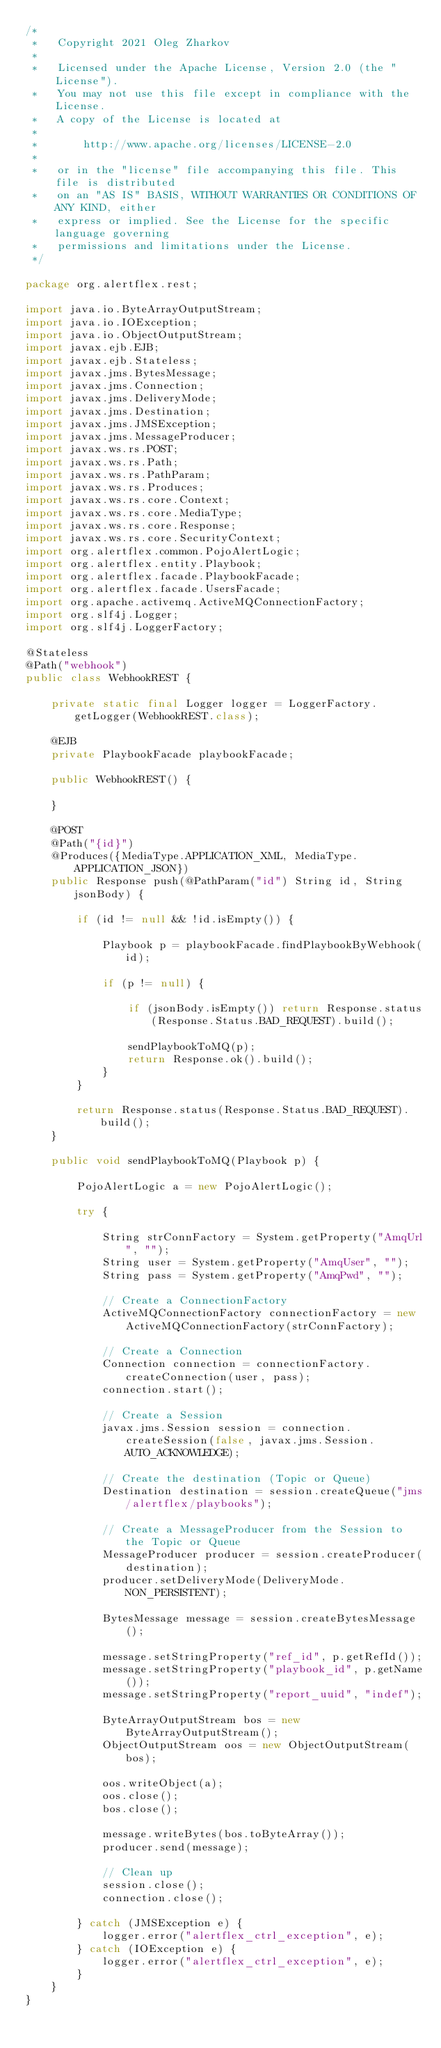Convert code to text. <code><loc_0><loc_0><loc_500><loc_500><_Java_>/*
 *   Copyright 2021 Oleg Zharkov
 *
 *   Licensed under the Apache License, Version 2.0 (the "License").
 *   You may not use this file except in compliance with the License.
 *   A copy of the License is located at
 *
 *       http://www.apache.org/licenses/LICENSE-2.0
 *
 *   or in the "license" file accompanying this file. This file is distributed
 *   on an "AS IS" BASIS, WITHOUT WARRANTIES OR CONDITIONS OF ANY KIND, either
 *   express or implied. See the License for the specific language governing
 *   permissions and limitations under the License.
 */

package org.alertflex.rest;

import java.io.ByteArrayOutputStream;
import java.io.IOException;
import java.io.ObjectOutputStream;
import javax.ejb.EJB;
import javax.ejb.Stateless;
import javax.jms.BytesMessage;
import javax.jms.Connection;
import javax.jms.DeliveryMode;
import javax.jms.Destination;
import javax.jms.JMSException;
import javax.jms.MessageProducer;
import javax.ws.rs.POST;
import javax.ws.rs.Path;
import javax.ws.rs.PathParam;
import javax.ws.rs.Produces;
import javax.ws.rs.core.Context;
import javax.ws.rs.core.MediaType;
import javax.ws.rs.core.Response;
import javax.ws.rs.core.SecurityContext;
import org.alertflex.common.PojoAlertLogic;
import org.alertflex.entity.Playbook;
import org.alertflex.facade.PlaybookFacade;
import org.alertflex.facade.UsersFacade;
import org.apache.activemq.ActiveMQConnectionFactory;
import org.slf4j.Logger;
import org.slf4j.LoggerFactory;

@Stateless
@Path("webhook")
public class WebhookREST {

    private static final Logger logger = LoggerFactory.getLogger(WebhookREST.class);

    @EJB
    private PlaybookFacade playbookFacade;

    public WebhookREST() {

    }

    @POST
    @Path("{id}")
    @Produces({MediaType.APPLICATION_XML, MediaType.APPLICATION_JSON})
    public Response push(@PathParam("id") String id, String jsonBody) {

        if (id != null && !id.isEmpty()) {

            Playbook p = playbookFacade.findPlaybookByWebhook(id);

            if (p != null) {
                
                if (jsonBody.isEmpty()) return Response.status(Response.Status.BAD_REQUEST).build();

                sendPlaybookToMQ(p);
                return Response.ok().build();
            }
        }

        return Response.status(Response.Status.BAD_REQUEST).build();
    }

    public void sendPlaybookToMQ(Playbook p) {
    
        PojoAlertLogic a = new PojoAlertLogic();
        
        try {

            String strConnFactory = System.getProperty("AmqUrl", "");
            String user = System.getProperty("AmqUser", "");
            String pass = System.getProperty("AmqPwd", "");

            // Create a ConnectionFactory
            ActiveMQConnectionFactory connectionFactory = new ActiveMQConnectionFactory(strConnFactory);

            // Create a Connection
            Connection connection = connectionFactory.createConnection(user, pass);
            connection.start();

            // Create a Session
            javax.jms.Session session = connection.createSession(false, javax.jms.Session.AUTO_ACKNOWLEDGE);

            // Create the destination (Topic or Queue)
            Destination destination = session.createQueue("jms/alertflex/playbooks");

            // Create a MessageProducer from the Session to the Topic or Queue
            MessageProducer producer = session.createProducer(destination);
            producer.setDeliveryMode(DeliveryMode.NON_PERSISTENT);
            
            BytesMessage message = session.createBytesMessage();

            message.setStringProperty("ref_id", p.getRefId());
            message.setStringProperty("playbook_id", p.getName());
            message.setStringProperty("report_uuid", "indef");
            
            ByteArrayOutputStream bos = new ByteArrayOutputStream();
            ObjectOutputStream oos = new ObjectOutputStream(bos);
                        
            oos.writeObject(a);
            oos.close();
            bos.close();
            
            message.writeBytes(bos.toByteArray());
            producer.send(message);
            
            // Clean up
            session.close();
            connection.close();

        } catch (JMSException e) {
            logger.error("alertflex_ctrl_exception", e);
        } catch (IOException e) {
            logger.error("alertflex_ctrl_exception", e);
        }
    }
}
</code> 